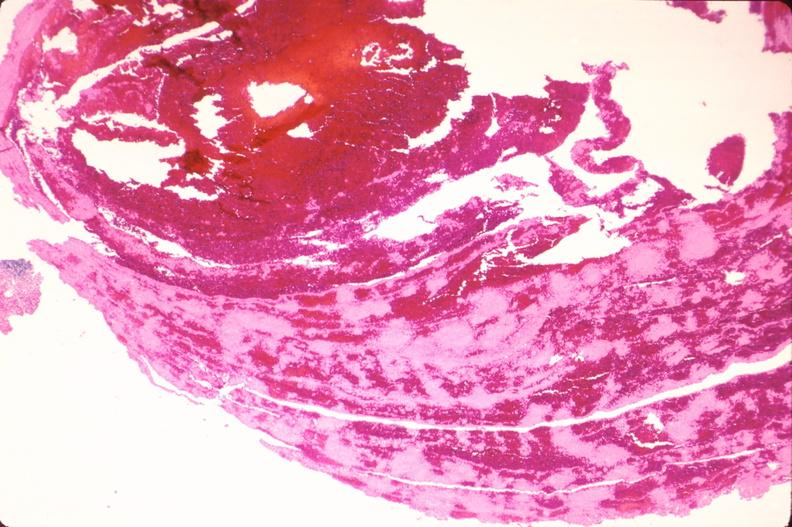where is this in?
Answer the question using a single word or phrase. Vasculature 